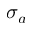<formula> <loc_0><loc_0><loc_500><loc_500>\sigma _ { a }</formula> 